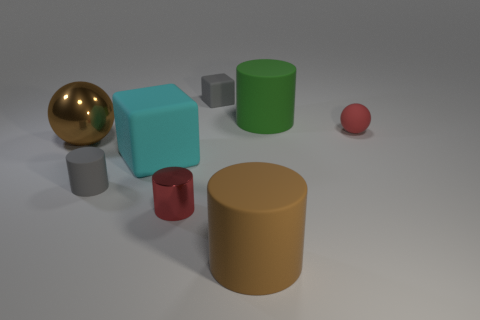Subtract all shiny cylinders. How many cylinders are left? 3 Add 2 purple matte spheres. How many objects exist? 10 Subtract all red cylinders. How many cylinders are left? 3 Subtract all blocks. How many objects are left? 6 Subtract all tiny red cylinders. Subtract all large brown things. How many objects are left? 5 Add 4 large brown cylinders. How many large brown cylinders are left? 5 Add 3 large brown matte objects. How many large brown matte objects exist? 4 Subtract 1 green cylinders. How many objects are left? 7 Subtract all yellow cylinders. Subtract all blue cubes. How many cylinders are left? 4 